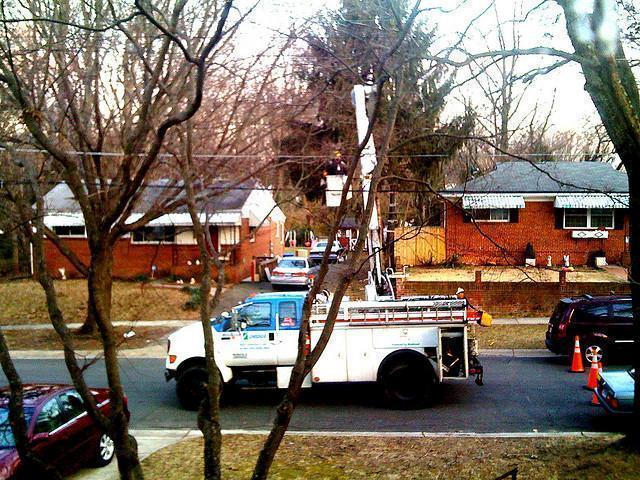Who is the man in the white platform?
Pick the correct solution from the four options below to address the question.
Options: Firefighter, policeman, utility worker, stuntman. Utility worker. 